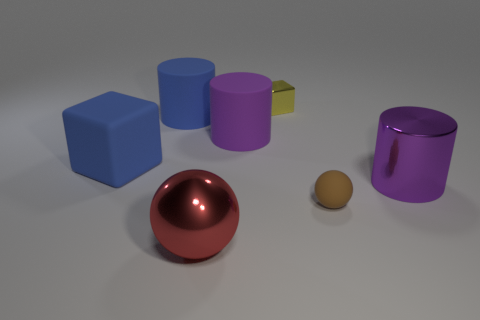Add 2 yellow things. How many objects exist? 9 Subtract all cylinders. How many objects are left? 4 Add 2 big purple matte things. How many big purple matte things are left? 3 Add 2 tiny gray metal spheres. How many tiny gray metal spheres exist? 2 Subtract 0 green blocks. How many objects are left? 7 Subtract all red metal things. Subtract all brown matte things. How many objects are left? 5 